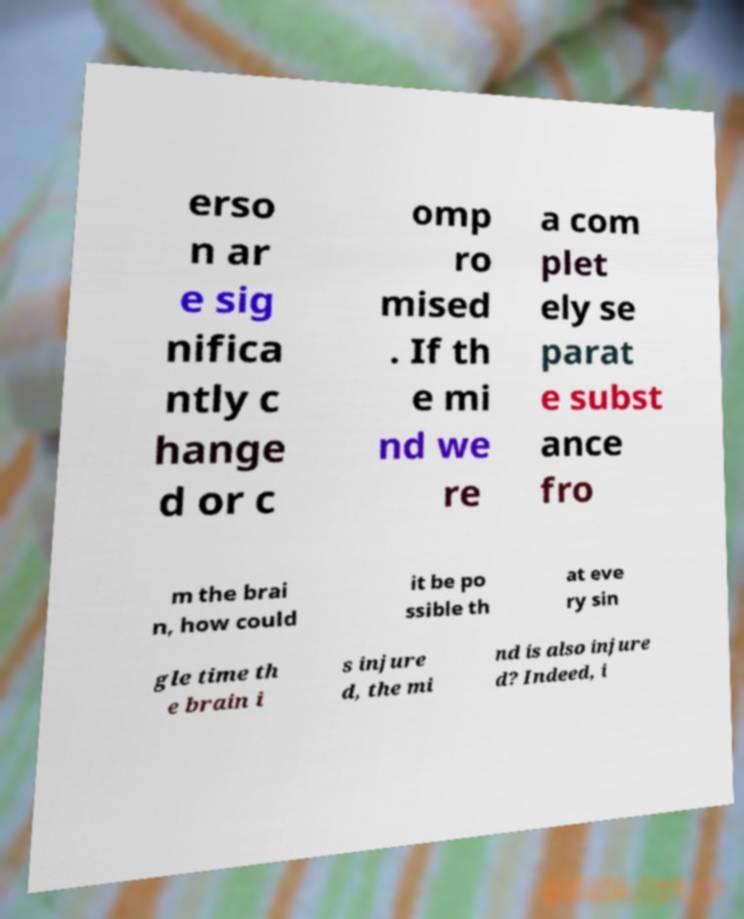I need the written content from this picture converted into text. Can you do that? erso n ar e sig nifica ntly c hange d or c omp ro mised . If th e mi nd we re a com plet ely se parat e subst ance fro m the brai n, how could it be po ssible th at eve ry sin gle time th e brain i s injure d, the mi nd is also injure d? Indeed, i 